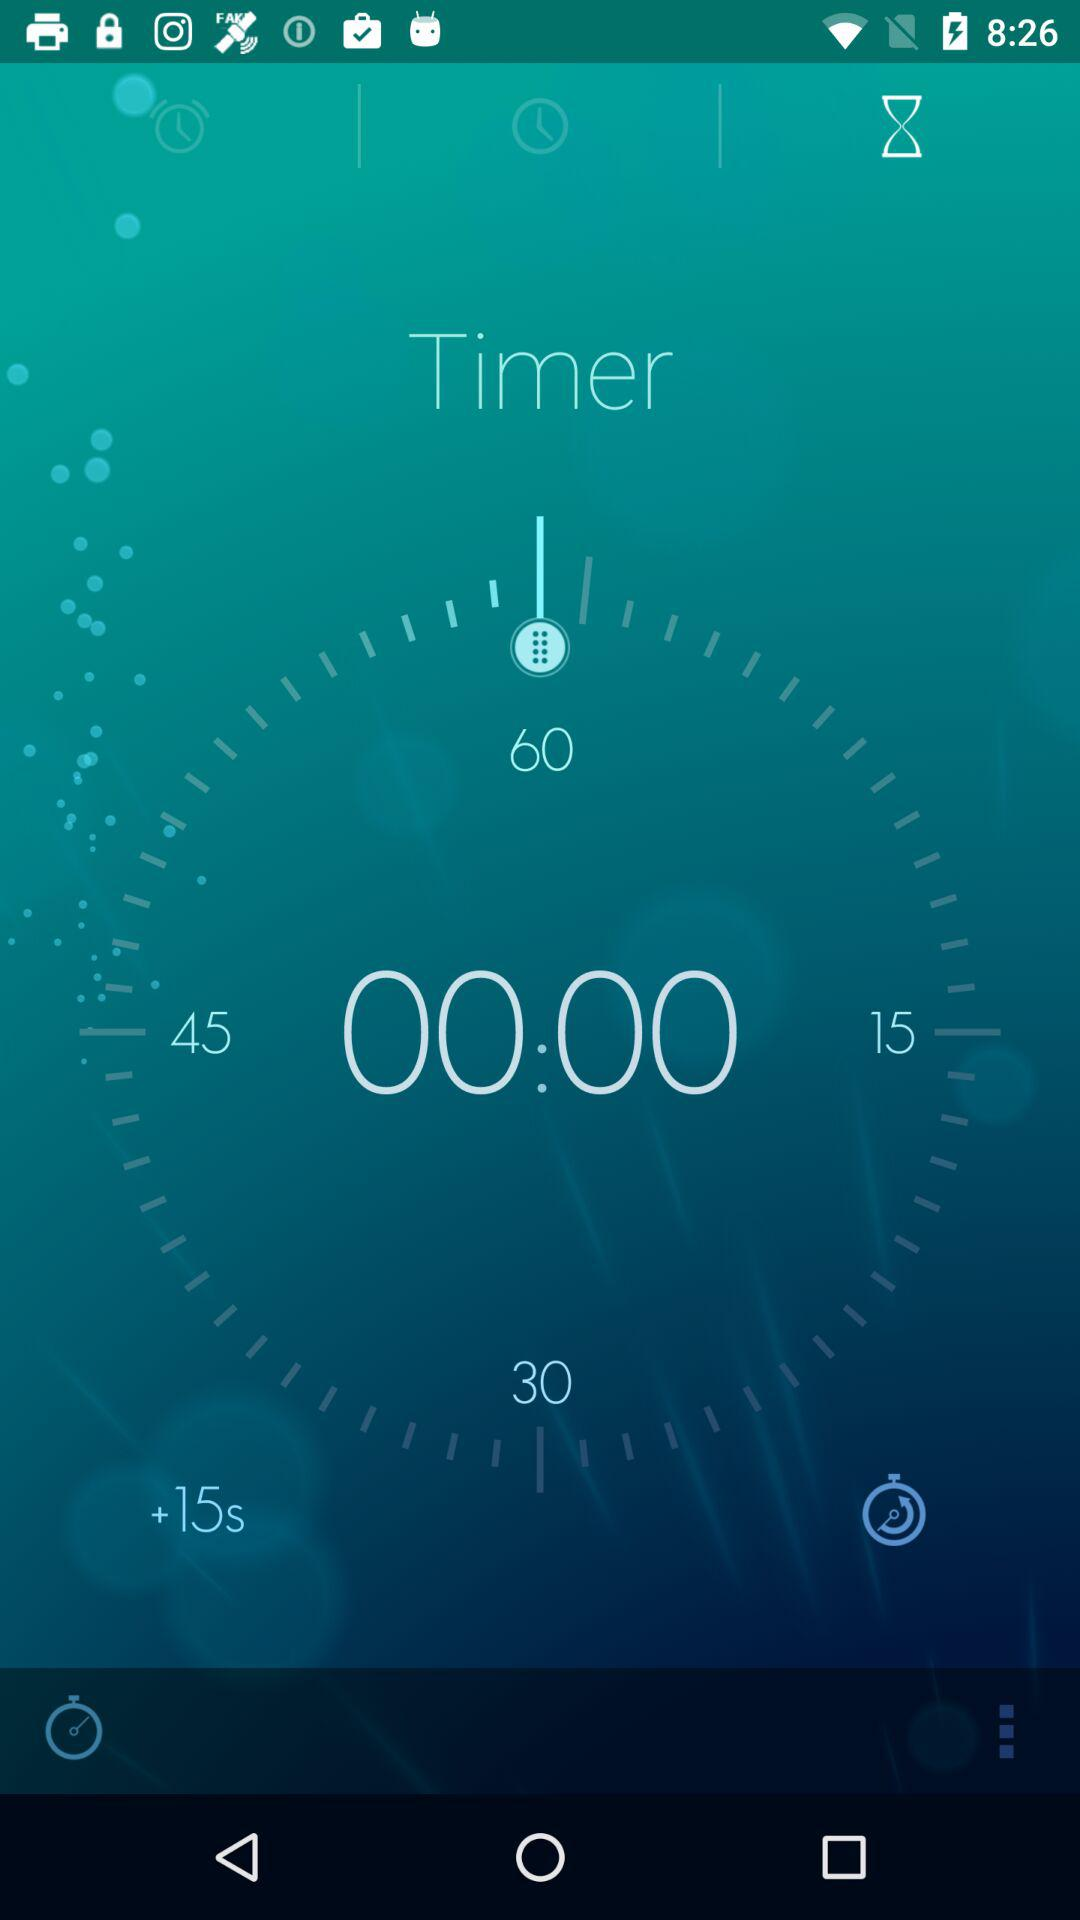What is the difference between the shortest and longest time displayed?
Answer the question using a single word or phrase. 45 